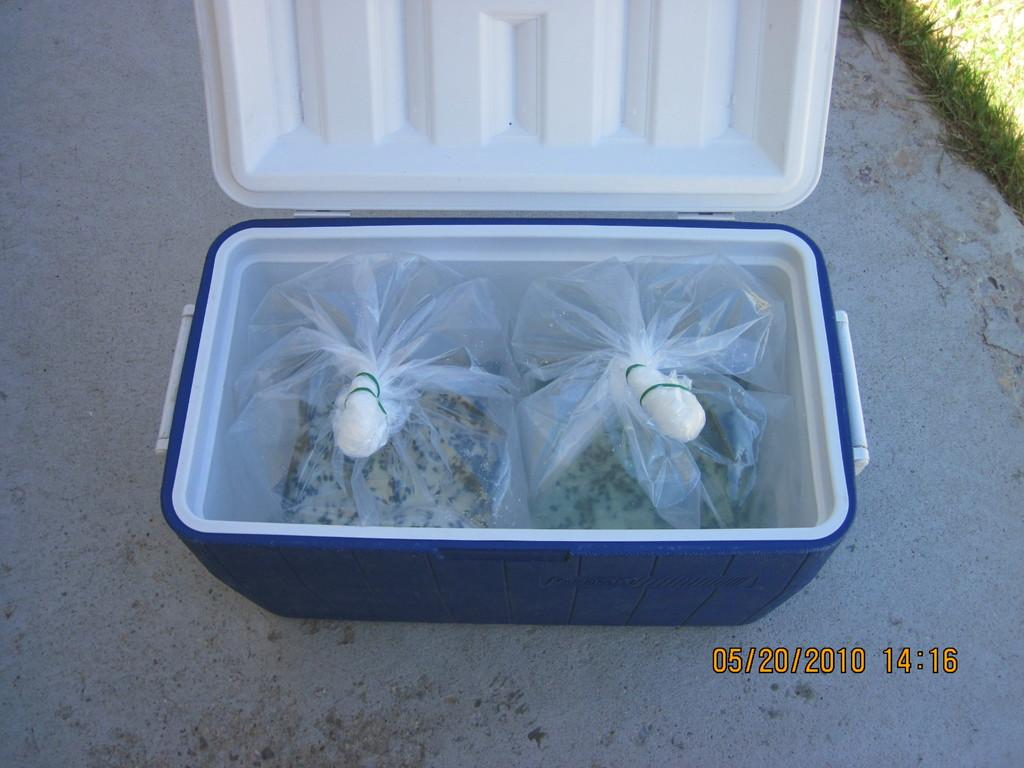What type of items can be seen in the image? There are food packets in the image. What additional information is displayed in the image? There is a date and time displayed in the image. What type of vegetation is visible in the image? There is grass in the right side corner of the image. What type of substance is being measured on the calculator in the image? There is no calculator present in the image, so it is not possible to answer that question. 